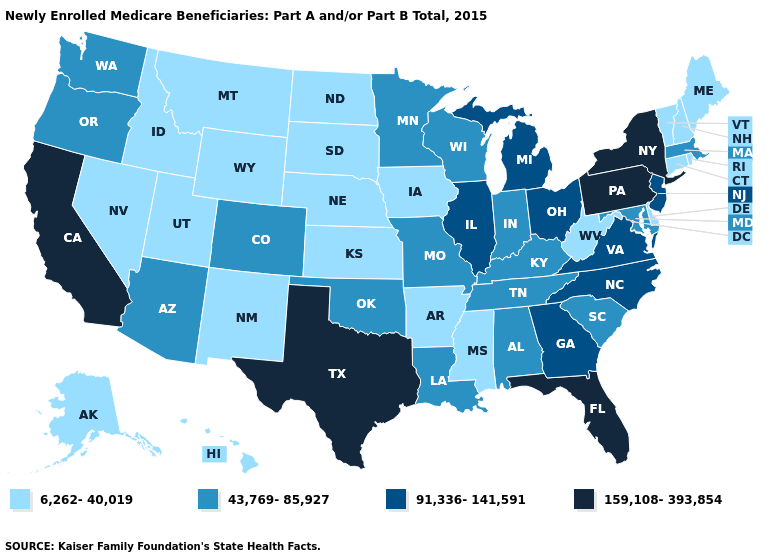What is the lowest value in states that border Ohio?
Give a very brief answer. 6,262-40,019. Name the states that have a value in the range 159,108-393,854?
Answer briefly. California, Florida, New York, Pennsylvania, Texas. Does Alaska have the lowest value in the USA?
Keep it brief. Yes. Does Georgia have the lowest value in the South?
Write a very short answer. No. Among the states that border Kansas , does Nebraska have the lowest value?
Write a very short answer. Yes. What is the lowest value in the MidWest?
Quick response, please. 6,262-40,019. Does Michigan have the same value as Illinois?
Answer briefly. Yes. Does Texas have the highest value in the USA?
Give a very brief answer. Yes. Name the states that have a value in the range 43,769-85,927?
Keep it brief. Alabama, Arizona, Colorado, Indiana, Kentucky, Louisiana, Maryland, Massachusetts, Minnesota, Missouri, Oklahoma, Oregon, South Carolina, Tennessee, Washington, Wisconsin. Among the states that border Texas , which have the lowest value?
Short answer required. Arkansas, New Mexico. Name the states that have a value in the range 43,769-85,927?
Keep it brief. Alabama, Arizona, Colorado, Indiana, Kentucky, Louisiana, Maryland, Massachusetts, Minnesota, Missouri, Oklahoma, Oregon, South Carolina, Tennessee, Washington, Wisconsin. What is the value of Wisconsin?
Concise answer only. 43,769-85,927. What is the highest value in the USA?
Keep it brief. 159,108-393,854. What is the lowest value in states that border Wyoming?
Answer briefly. 6,262-40,019. What is the lowest value in the MidWest?
Write a very short answer. 6,262-40,019. 